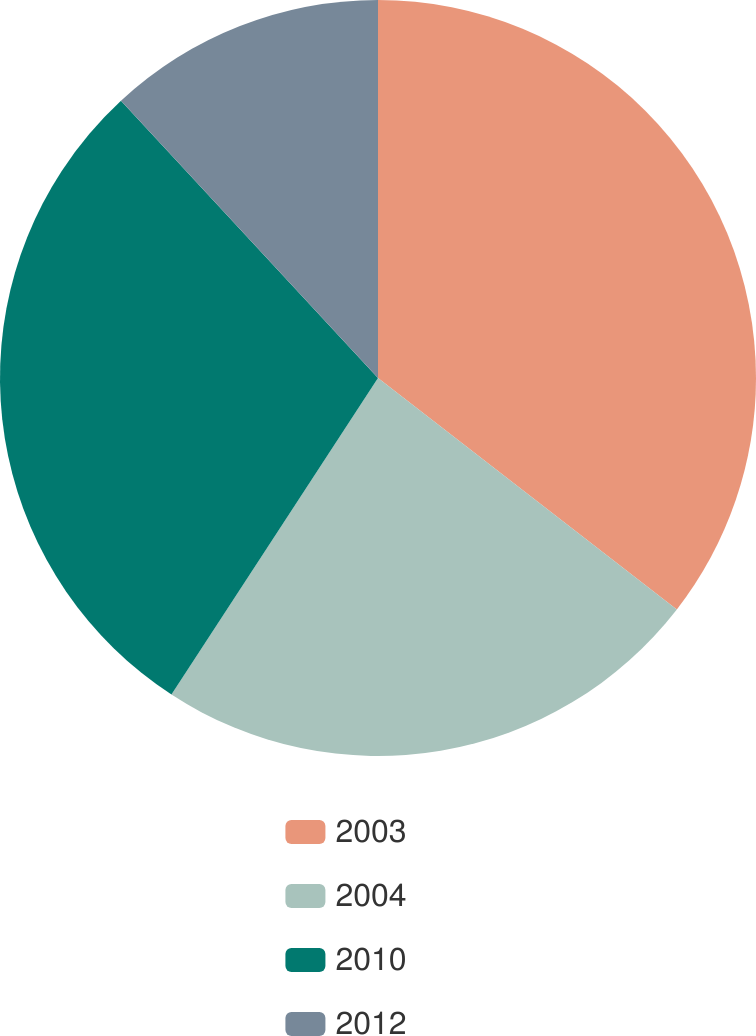Convert chart to OTSL. <chart><loc_0><loc_0><loc_500><loc_500><pie_chart><fcel>2003<fcel>2004<fcel>2010<fcel>2012<nl><fcel>35.49%<fcel>23.71%<fcel>28.9%<fcel>11.9%<nl></chart> 